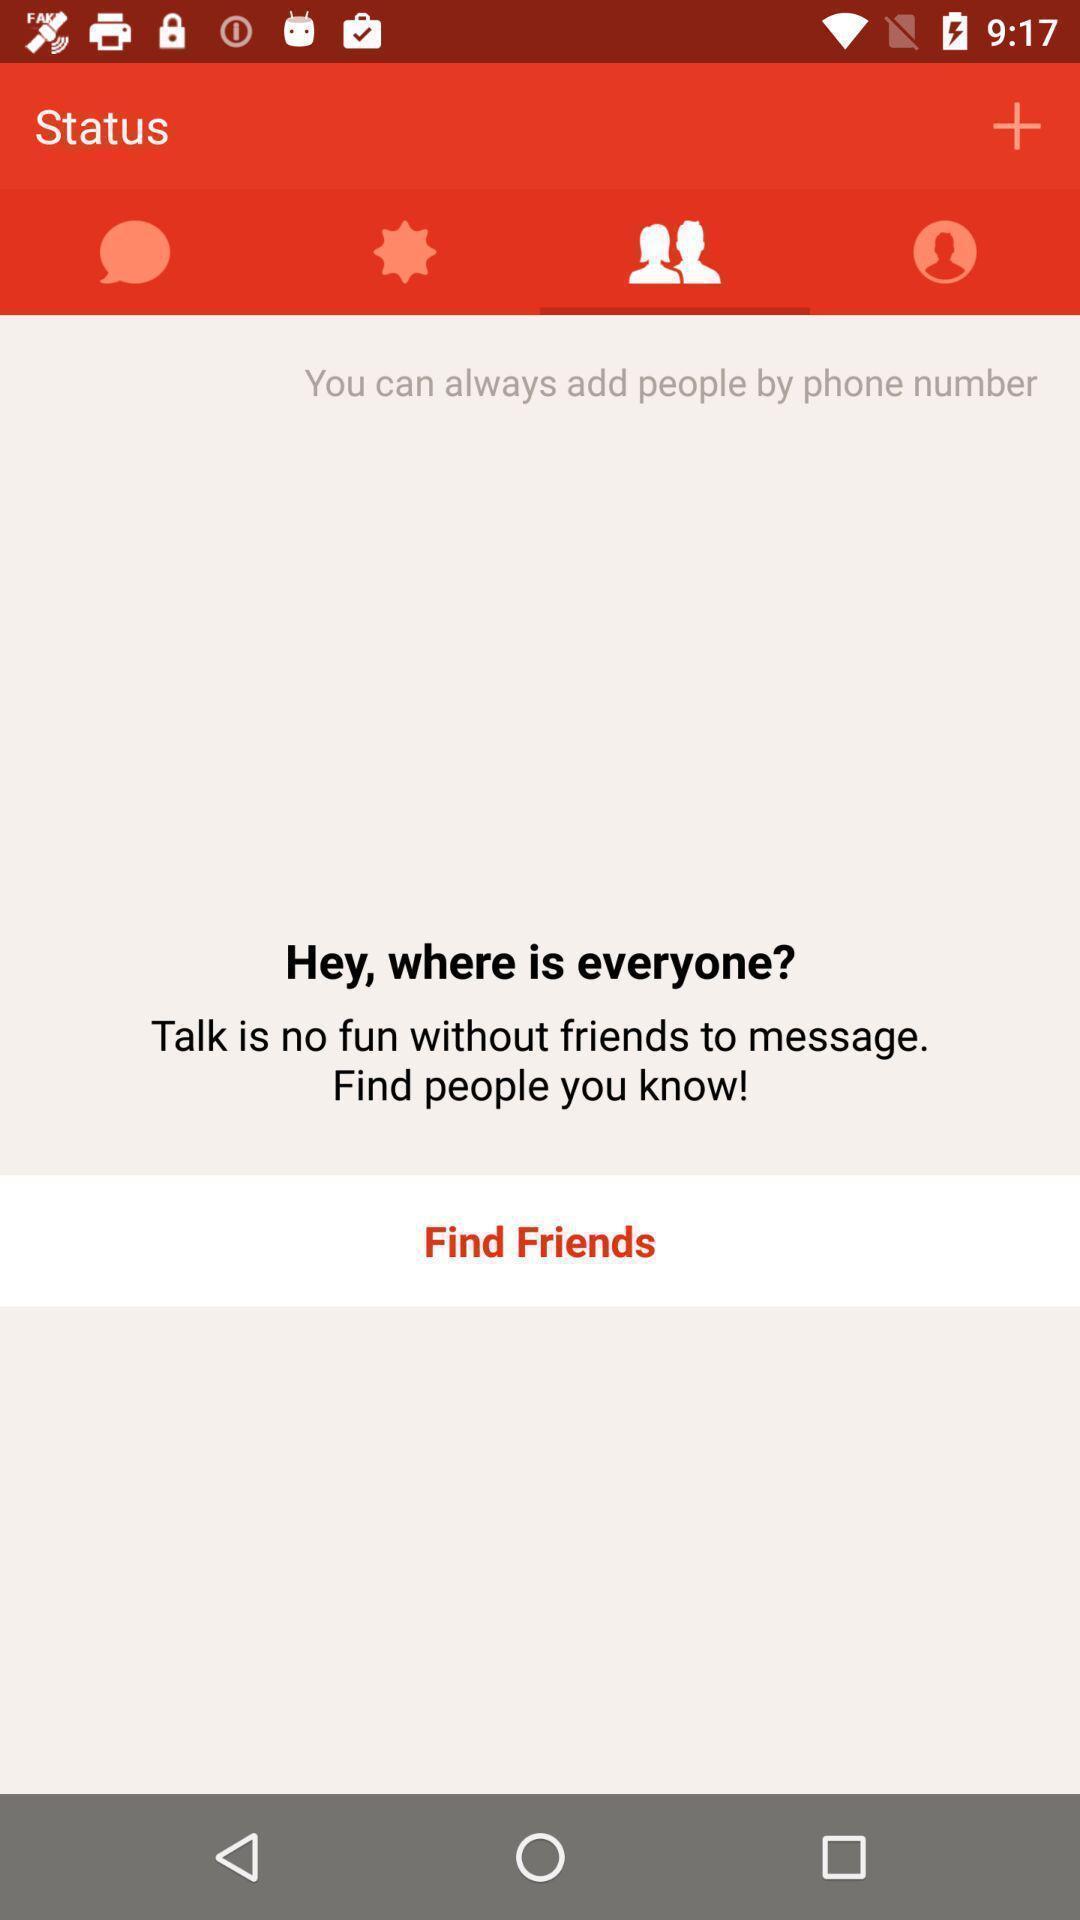Explain the elements present in this screenshot. Screen page displaying multiple options in social application. 